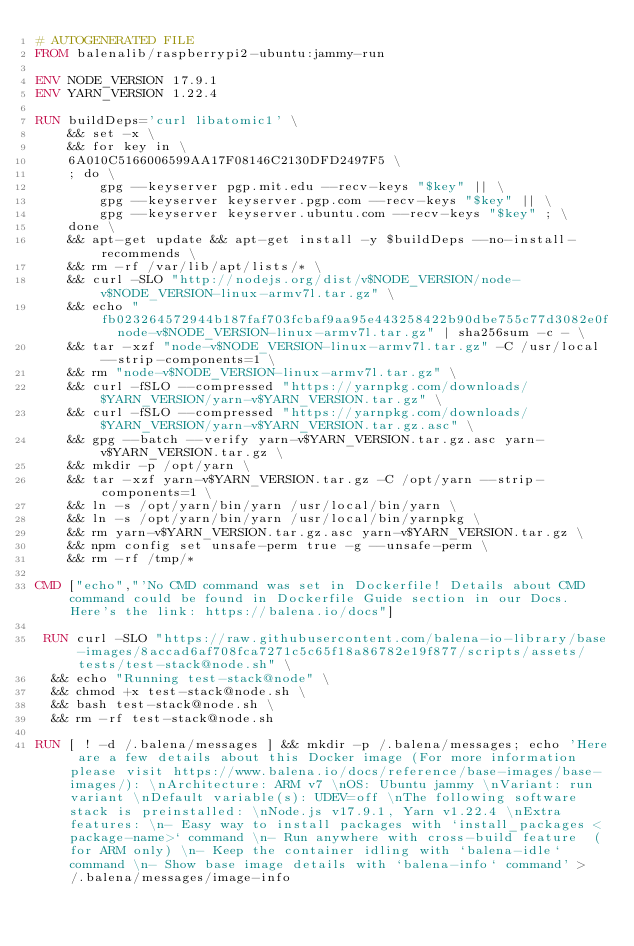Convert code to text. <code><loc_0><loc_0><loc_500><loc_500><_Dockerfile_># AUTOGENERATED FILE
FROM balenalib/raspberrypi2-ubuntu:jammy-run

ENV NODE_VERSION 17.9.1
ENV YARN_VERSION 1.22.4

RUN buildDeps='curl libatomic1' \
	&& set -x \
	&& for key in \
	6A010C5166006599AA17F08146C2130DFD2497F5 \
	; do \
		gpg --keyserver pgp.mit.edu --recv-keys "$key" || \
		gpg --keyserver keyserver.pgp.com --recv-keys "$key" || \
		gpg --keyserver keyserver.ubuntu.com --recv-keys "$key" ; \
	done \
	&& apt-get update && apt-get install -y $buildDeps --no-install-recommends \
	&& rm -rf /var/lib/apt/lists/* \
	&& curl -SLO "http://nodejs.org/dist/v$NODE_VERSION/node-v$NODE_VERSION-linux-armv7l.tar.gz" \
	&& echo "fb023264572944b187faf703fcbaf9aa95e443258422b90dbe755c77d3082e0f  node-v$NODE_VERSION-linux-armv7l.tar.gz" | sha256sum -c - \
	&& tar -xzf "node-v$NODE_VERSION-linux-armv7l.tar.gz" -C /usr/local --strip-components=1 \
	&& rm "node-v$NODE_VERSION-linux-armv7l.tar.gz" \
	&& curl -fSLO --compressed "https://yarnpkg.com/downloads/$YARN_VERSION/yarn-v$YARN_VERSION.tar.gz" \
	&& curl -fSLO --compressed "https://yarnpkg.com/downloads/$YARN_VERSION/yarn-v$YARN_VERSION.tar.gz.asc" \
	&& gpg --batch --verify yarn-v$YARN_VERSION.tar.gz.asc yarn-v$YARN_VERSION.tar.gz \
	&& mkdir -p /opt/yarn \
	&& tar -xzf yarn-v$YARN_VERSION.tar.gz -C /opt/yarn --strip-components=1 \
	&& ln -s /opt/yarn/bin/yarn /usr/local/bin/yarn \
	&& ln -s /opt/yarn/bin/yarn /usr/local/bin/yarnpkg \
	&& rm yarn-v$YARN_VERSION.tar.gz.asc yarn-v$YARN_VERSION.tar.gz \
	&& npm config set unsafe-perm true -g --unsafe-perm \
	&& rm -rf /tmp/*

CMD ["echo","'No CMD command was set in Dockerfile! Details about CMD command could be found in Dockerfile Guide section in our Docs. Here's the link: https://balena.io/docs"]

 RUN curl -SLO "https://raw.githubusercontent.com/balena-io-library/base-images/8accad6af708fca7271c5c65f18a86782e19f877/scripts/assets/tests/test-stack@node.sh" \
  && echo "Running test-stack@node" \
  && chmod +x test-stack@node.sh \
  && bash test-stack@node.sh \
  && rm -rf test-stack@node.sh 

RUN [ ! -d /.balena/messages ] && mkdir -p /.balena/messages; echo 'Here are a few details about this Docker image (For more information please visit https://www.balena.io/docs/reference/base-images/base-images/): \nArchitecture: ARM v7 \nOS: Ubuntu jammy \nVariant: run variant \nDefault variable(s): UDEV=off \nThe following software stack is preinstalled: \nNode.js v17.9.1, Yarn v1.22.4 \nExtra features: \n- Easy way to install packages with `install_packages <package-name>` command \n- Run anywhere with cross-build feature  (for ARM only) \n- Keep the container idling with `balena-idle` command \n- Show base image details with `balena-info` command' > /.balena/messages/image-info</code> 